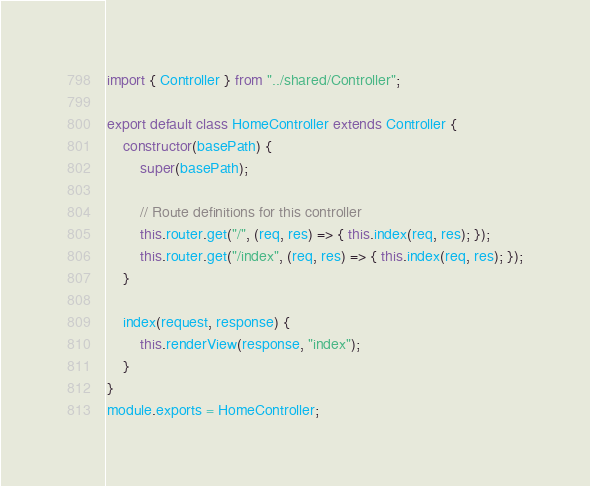Convert code to text. <code><loc_0><loc_0><loc_500><loc_500><_JavaScript_>import { Controller } from "../shared/Controller";

export default class HomeController extends Controller {
    constructor(basePath) {
        super(basePath);

        // Route definitions for this controller
        this.router.get("/", (req, res) => { this.index(req, res); });
        this.router.get("/index", (req, res) => { this.index(req, res); });
    }

    index(request, response) {
        this.renderView(response, "index");
    }
}
module.exports = HomeController;</code> 